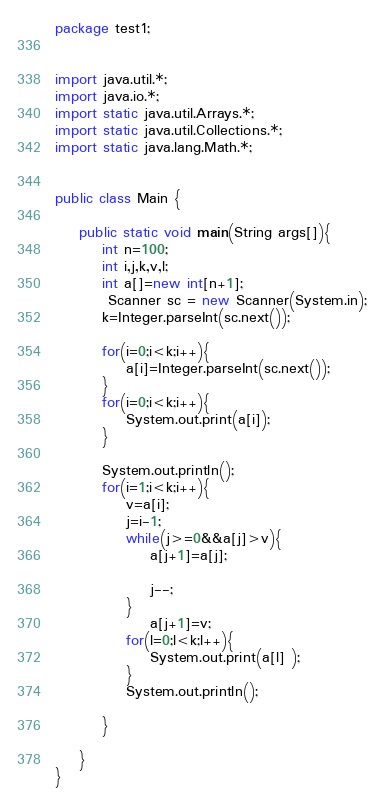<code> <loc_0><loc_0><loc_500><loc_500><_Java_>package test1;


import java.util.*;
import java.io.*;
import static java.util.Arrays.*;
import static java.util.Collections.*;
import static java.lang.Math.*;


public class Main {

	public static void main(String args[]){
		int n=100;
		int i,j,k,v,l;
		int a[]=new int[n+1];
		 Scanner sc = new Scanner(System.in);
		k=Integer.parseInt(sc.next());
		
		for(i=0;i<k;i++){
			a[i]=Integer.parseInt(sc.next());
		}
		for(i=0;i<k;i++){
			System.out.print(a[i]);
		}
		
		System.out.println();
		for(i=1;i<k;i++){
			v=a[i];
			j=i-1;
			while(j>=0&&a[j]>v){
				a[j+1]=a[j];
			
				j--;
			}
				a[j+1]=v;
			for(l=0;l<k;l++){
				System.out.print(a[l] );
			}
			System.out.println();
			
		}
		
	}
}</code> 